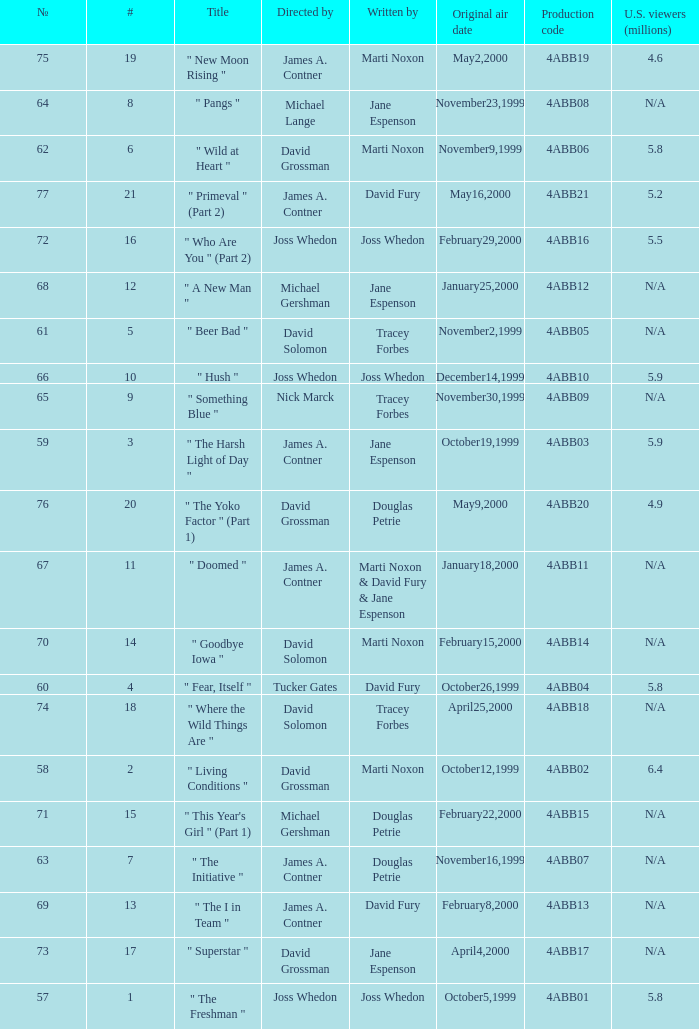What is the production code for the episode with 5.5 million u.s. viewers? 4ABB16. Write the full table. {'header': ['№', '#', 'Title', 'Directed by', 'Written by', 'Original air date', 'Production code', 'U.S. viewers (millions)'], 'rows': [['75', '19', '" New Moon Rising "', 'James A. Contner', 'Marti Noxon', 'May2,2000', '4ABB19', '4.6'], ['64', '8', '" Pangs "', 'Michael Lange', 'Jane Espenson', 'November23,1999', '4ABB08', 'N/A'], ['62', '6', '" Wild at Heart "', 'David Grossman', 'Marti Noxon', 'November9,1999', '4ABB06', '5.8'], ['77', '21', '" Primeval " (Part 2)', 'James A. Contner', 'David Fury', 'May16,2000', '4ABB21', '5.2'], ['72', '16', '" Who Are You " (Part 2)', 'Joss Whedon', 'Joss Whedon', 'February29,2000', '4ABB16', '5.5'], ['68', '12', '" A New Man "', 'Michael Gershman', 'Jane Espenson', 'January25,2000', '4ABB12', 'N/A'], ['61', '5', '" Beer Bad "', 'David Solomon', 'Tracey Forbes', 'November2,1999', '4ABB05', 'N/A'], ['66', '10', '" Hush "', 'Joss Whedon', 'Joss Whedon', 'December14,1999', '4ABB10', '5.9'], ['65', '9', '" Something Blue "', 'Nick Marck', 'Tracey Forbes', 'November30,1999', '4ABB09', 'N/A'], ['59', '3', '" The Harsh Light of Day "', 'James A. Contner', 'Jane Espenson', 'October19,1999', '4ABB03', '5.9'], ['76', '20', '" The Yoko Factor " (Part 1)', 'David Grossman', 'Douglas Petrie', 'May9,2000', '4ABB20', '4.9'], ['67', '11', '" Doomed "', 'James A. Contner', 'Marti Noxon & David Fury & Jane Espenson', 'January18,2000', '4ABB11', 'N/A'], ['70', '14', '" Goodbye Iowa "', 'David Solomon', 'Marti Noxon', 'February15,2000', '4ABB14', 'N/A'], ['60', '4', '" Fear, Itself "', 'Tucker Gates', 'David Fury', 'October26,1999', '4ABB04', '5.8'], ['74', '18', '" Where the Wild Things Are "', 'David Solomon', 'Tracey Forbes', 'April25,2000', '4ABB18', 'N/A'], ['58', '2', '" Living Conditions "', 'David Grossman', 'Marti Noxon', 'October12,1999', '4ABB02', '6.4'], ['71', '15', '" This Year\'s Girl " (Part 1)', 'Michael Gershman', 'Douglas Petrie', 'February22,2000', '4ABB15', 'N/A'], ['63', '7', '" The Initiative "', 'James A. Contner', 'Douglas Petrie', 'November16,1999', '4ABB07', 'N/A'], ['69', '13', '" The I in Team "', 'James A. Contner', 'David Fury', 'February8,2000', '4ABB13', 'N/A'], ['73', '17', '" Superstar "', 'David Grossman', 'Jane Espenson', 'April4,2000', '4ABB17', 'N/A'], ['57', '1', '" The Freshman "', 'Joss Whedon', 'Joss Whedon', 'October5,1999', '4ABB01', '5.8']]} 